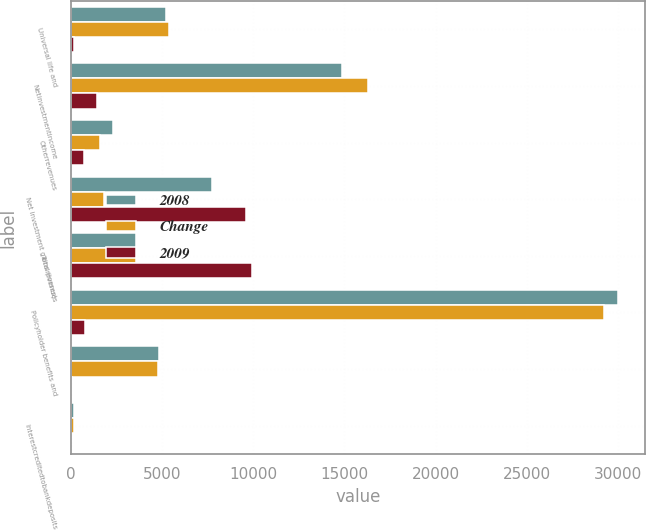<chart> <loc_0><loc_0><loc_500><loc_500><stacked_bar_chart><ecel><fcel>Universal life and<fcel>Netinvestmentincome<fcel>Otherrevenues<fcel>Net investment gains (losses)<fcel>Totalrevenues<fcel>Policyholder benefits and<fcel>Unnamed: 7<fcel>Interestcreditedtobankdeposits<nl><fcel>2008<fcel>5203<fcel>14838<fcel>2329<fcel>7772<fcel>3558.5<fcel>29986<fcel>4849<fcel>163<nl><fcel>Change<fcel>5381<fcel>16291<fcel>1586<fcel>1812<fcel>3558.5<fcel>29188<fcel>4788<fcel>166<nl><fcel>2009<fcel>178<fcel>1453<fcel>743<fcel>9584<fcel>9926<fcel>798<fcel>61<fcel>3<nl></chart> 